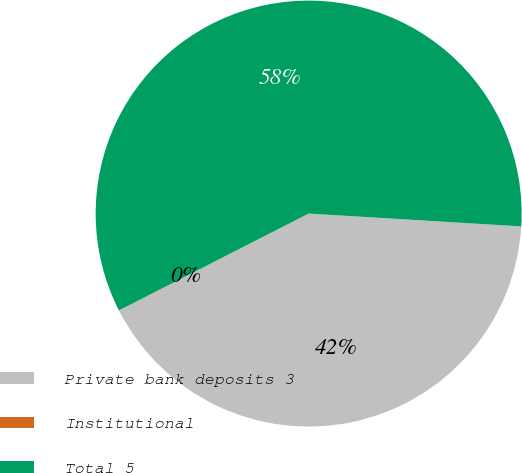<chart> <loc_0><loc_0><loc_500><loc_500><pie_chart><fcel>Private bank deposits 3<fcel>Institutional<fcel>Total 5<nl><fcel>41.53%<fcel>0.0%<fcel>58.47%<nl></chart> 